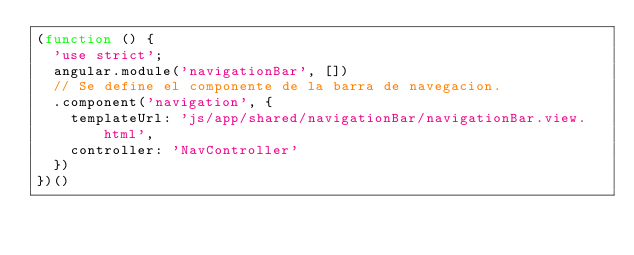Convert code to text. <code><loc_0><loc_0><loc_500><loc_500><_JavaScript_>(function () {
  'use strict';
  angular.module('navigationBar', [])
  // Se define el componente de la barra de navegacion.
  .component('navigation', {
    templateUrl: 'js/app/shared/navigationBar/navigationBar.view.html',
    controller: 'NavController'
  })
})()
</code> 